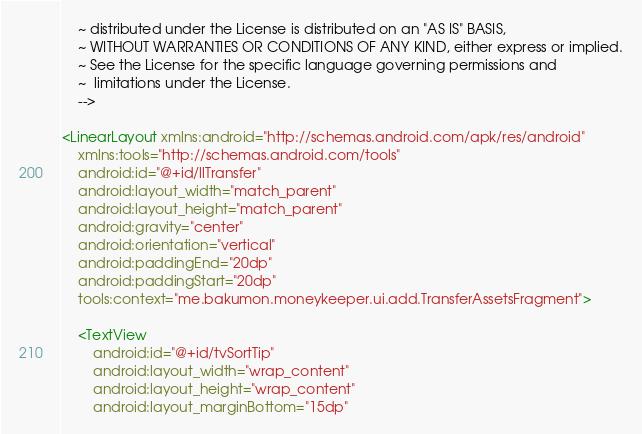Convert code to text. <code><loc_0><loc_0><loc_500><loc_500><_XML_>    ~ distributed under the License is distributed on an "AS IS" BASIS,
    ~ WITHOUT WARRANTIES OR CONDITIONS OF ANY KIND, either express or implied.
    ~ See the License for the specific language governing permissions and
    ~  limitations under the License.
    -->

<LinearLayout xmlns:android="http://schemas.android.com/apk/res/android"
    xmlns:tools="http://schemas.android.com/tools"
    android:id="@+id/llTransfer"
    android:layout_width="match_parent"
    android:layout_height="match_parent"
    android:gravity="center"
    android:orientation="vertical"
    android:paddingEnd="20dp"
    android:paddingStart="20dp"
    tools:context="me.bakumon.moneykeeper.ui.add.TransferAssetsFragment">

    <TextView
        android:id="@+id/tvSortTip"
        android:layout_width="wrap_content"
        android:layout_height="wrap_content"
        android:layout_marginBottom="15dp"</code> 